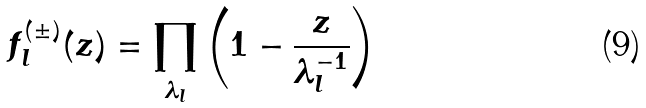<formula> <loc_0><loc_0><loc_500><loc_500>f _ { l } ^ { ( \pm ) } ( z ) = \prod _ { \lambda _ { l } } \left ( 1 - \frac { z } { \lambda _ { l } ^ { - 1 } } \right )</formula> 